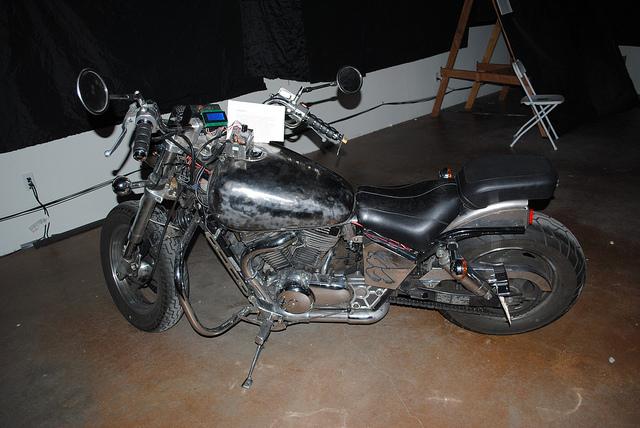Where is the chair?
Give a very brief answer. Behind motorcycle. Is this an old or new motorcycle?
Give a very brief answer. Old. Is the motorcycle inside?
Answer briefly. Yes. Is this a lowrider?
Write a very short answer. No. Is there more than three motorcycle?
Quick response, please. No. 